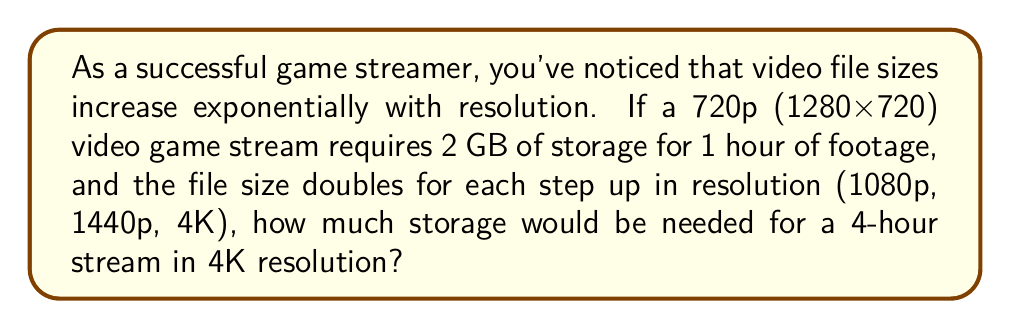Give your solution to this math problem. Let's approach this step-by-step:

1) First, let's identify the resolutions and their relative sizes:
   720p (1280x720) = 2 GB per hour (given)
   1080p (1920x1080) = 2 * 2 = 4 GB per hour
   1440p (2560x1440) = 4 * 2 = 8 GB per hour
   4K (3840x2160) = 8 * 2 = 16 GB per hour

2) We can express this as an exponential function:
   $$ \text{File size} = 2 \cdot 2^n $$
   Where $n$ is the number of steps up from 720p (0 for 720p, 1 for 1080p, 2 for 1440p, 3 for 4K)

3) For 4K, $n = 3$:
   $$ \text{File size per hour} = 2 \cdot 2^3 = 2 \cdot 8 = 16 \text{ GB} $$

4) The question asks for a 4-hour stream, so we multiply by 4:
   $$ \text{Total file size} = 16 \text{ GB/hour} \cdot 4 \text{ hours} = 64 \text{ GB} $$

Therefore, a 4-hour stream in 4K resolution would require 64 GB of storage.
Answer: 64 GB 